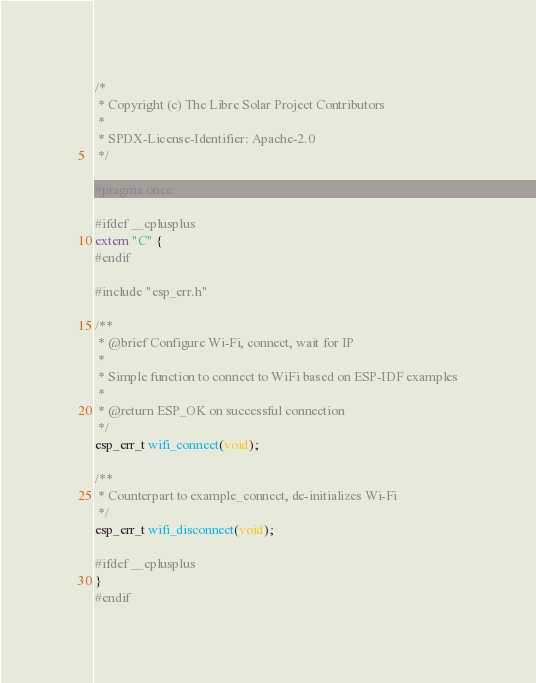Convert code to text. <code><loc_0><loc_0><loc_500><loc_500><_C_>/*
 * Copyright (c) The Libre Solar Project Contributors
 *
 * SPDX-License-Identifier: Apache-2.0
 */

#pragma once

#ifdef __cplusplus
extern "C" {
#endif

#include "esp_err.h"

/**
 * @brief Configure Wi-Fi, connect, wait for IP
 *
 * Simple function to connect to WiFi based on ESP-IDF examples
 *
 * @return ESP_OK on successful connection
 */
esp_err_t wifi_connect(void);

/**
 * Counterpart to example_connect, de-initializes Wi-Fi
 */
esp_err_t wifi_disconnect(void);

#ifdef __cplusplus
}
#endif
</code> 